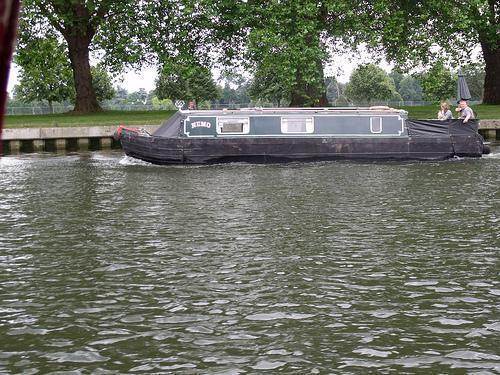How many boats are in the photo?
Give a very brief answer. 1. 